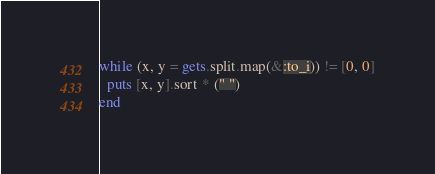Convert code to text. <code><loc_0><loc_0><loc_500><loc_500><_Ruby_>while (x, y = gets.split.map(&:to_i)) != [0, 0]
  puts [x, y].sort * (" ")
end</code> 